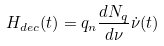<formula> <loc_0><loc_0><loc_500><loc_500>H _ { d e c } ( t ) = q _ { n } \frac { d N _ { q } } { d \nu } \dot { \nu } ( t )</formula> 